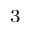<formula> <loc_0><loc_0><loc_500><loc_500>_ { 3 }</formula> 